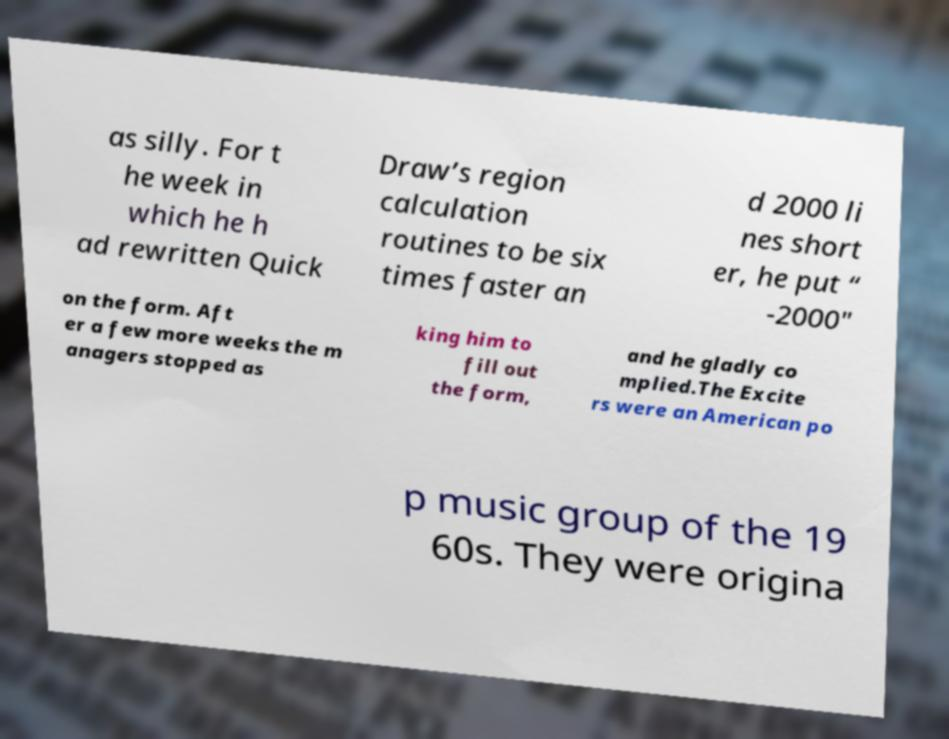Could you assist in decoding the text presented in this image and type it out clearly? as silly. For t he week in which he h ad rewritten Quick Draw’s region calculation routines to be six times faster an d 2000 li nes short er, he put “ -2000″ on the form. Aft er a few more weeks the m anagers stopped as king him to fill out the form, and he gladly co mplied.The Excite rs were an American po p music group of the 19 60s. They were origina 